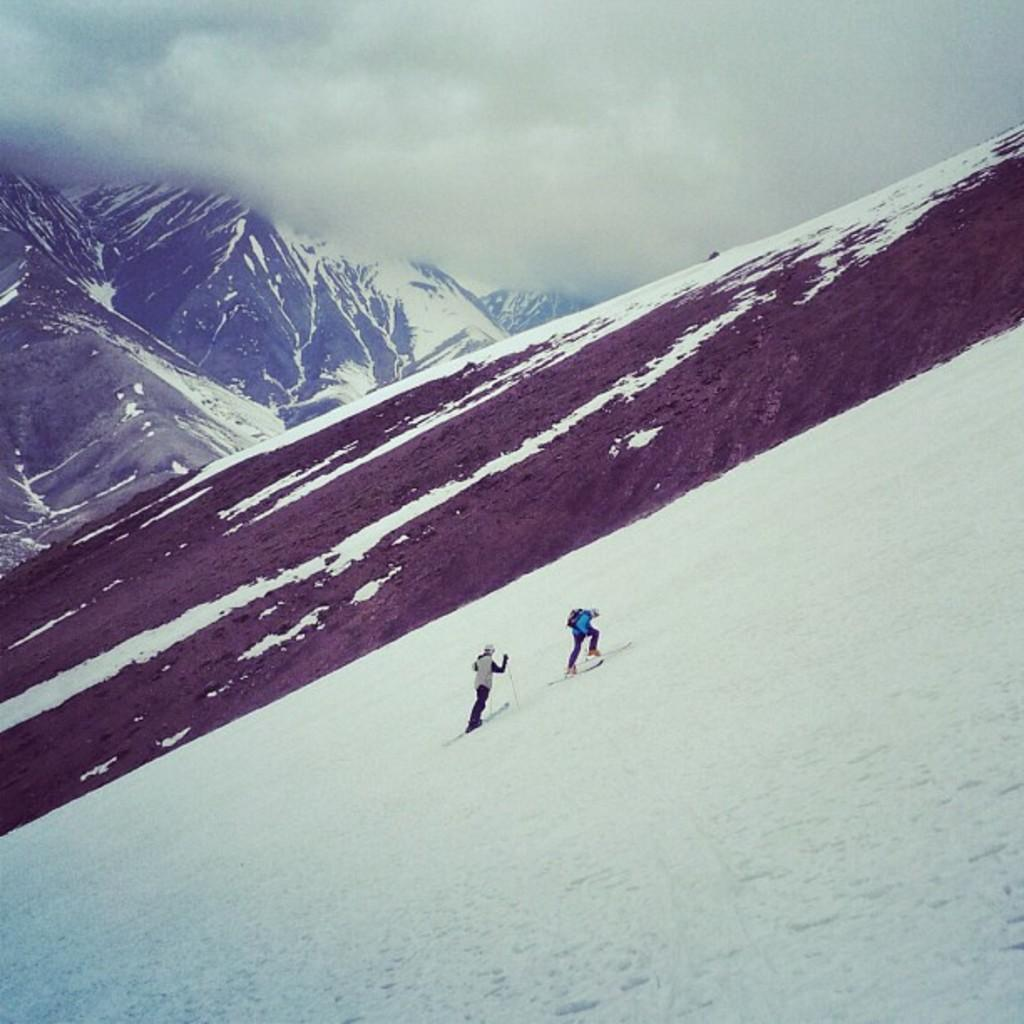What activity are the people in the image engaged in? The people in the image are skiing. What equipment are the people using to ski? The people are using skis to ski. On what surface is the skiing taking place? The skiing is taking place on ice. What can be seen in the background of the image? There are hills and clouds visible in the background of the image. What type of board is the donkey riding in the image? There is no donkey or board present in the image; it features people skiing on ice. 